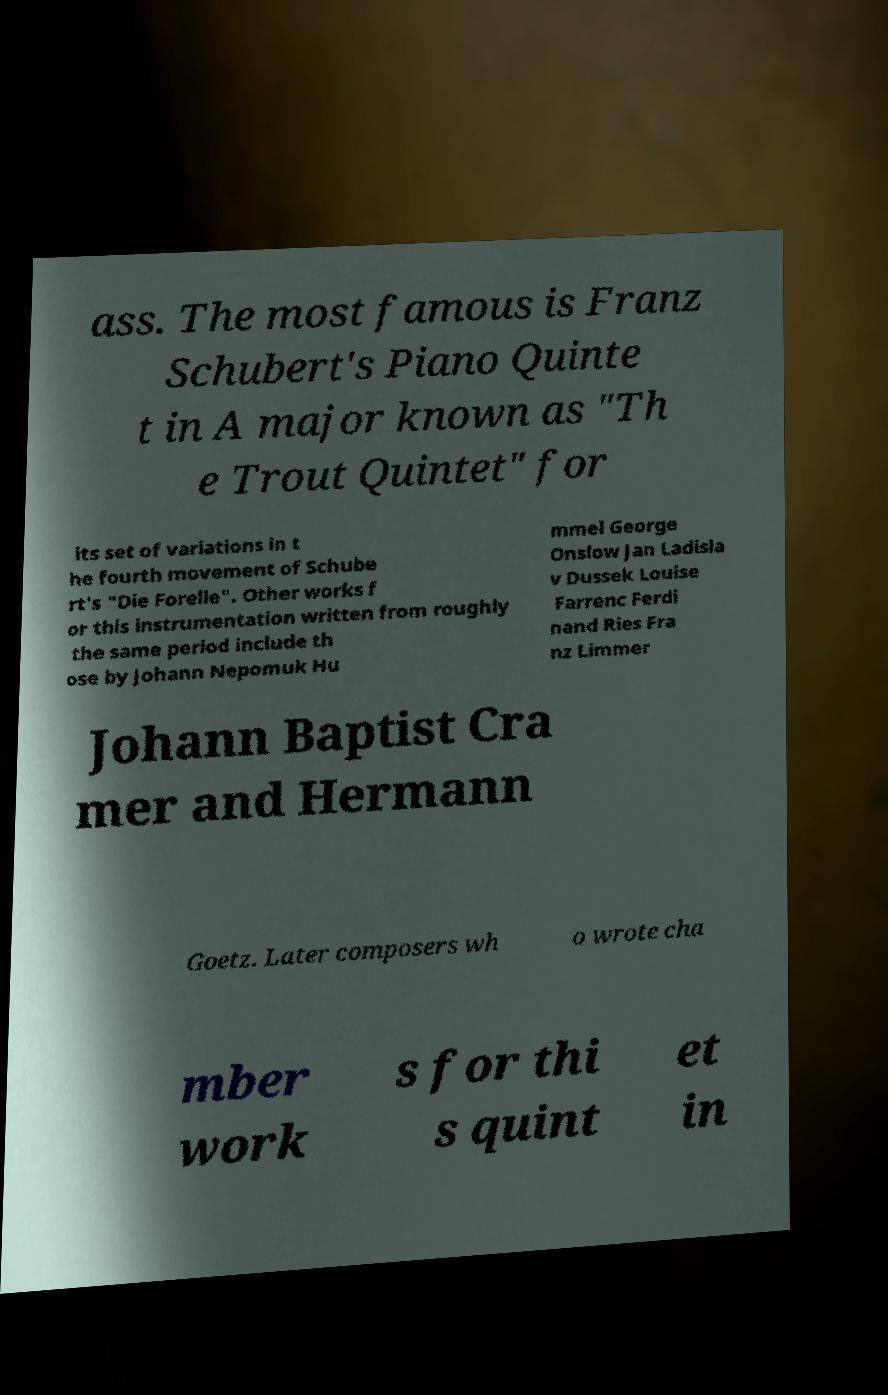Could you extract and type out the text from this image? ass. The most famous is Franz Schubert's Piano Quinte t in A major known as "Th e Trout Quintet" for its set of variations in t he fourth movement of Schube rt's "Die Forelle". Other works f or this instrumentation written from roughly the same period include th ose by Johann Nepomuk Hu mmel George Onslow Jan Ladisla v Dussek Louise Farrenc Ferdi nand Ries Fra nz Limmer Johann Baptist Cra mer and Hermann Goetz. Later composers wh o wrote cha mber work s for thi s quint et in 